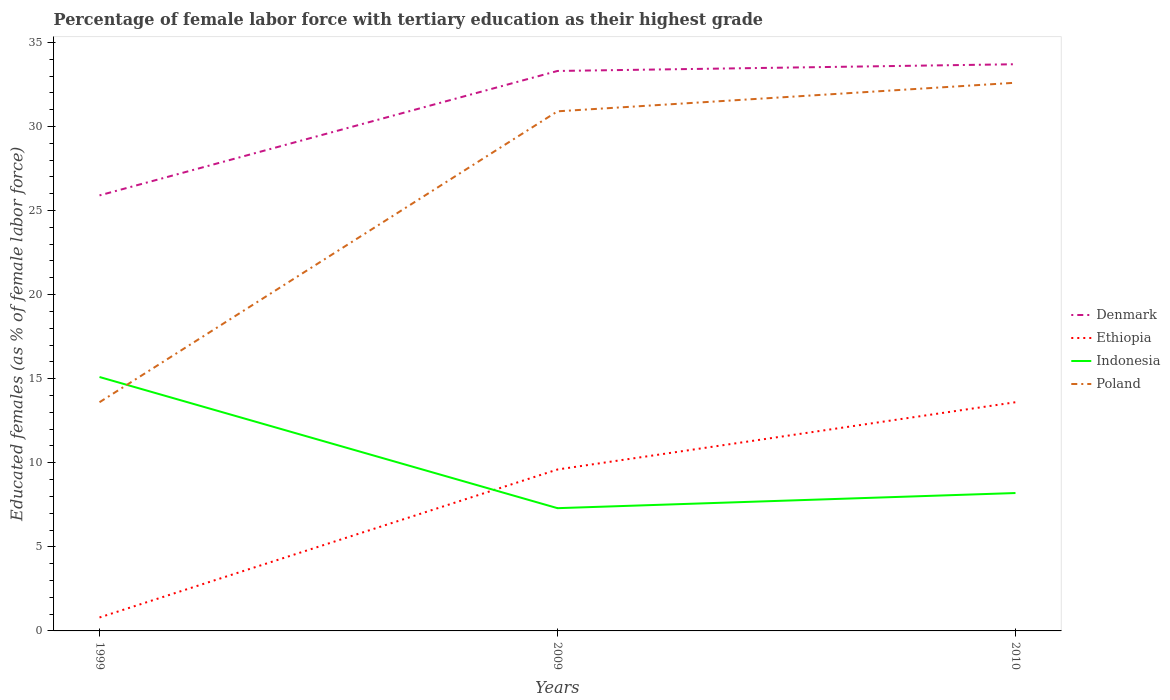Does the line corresponding to Indonesia intersect with the line corresponding to Denmark?
Make the answer very short. No. Is the number of lines equal to the number of legend labels?
Your response must be concise. Yes. Across all years, what is the maximum percentage of female labor force with tertiary education in Poland?
Give a very brief answer. 13.6. What is the total percentage of female labor force with tertiary education in Poland in the graph?
Your answer should be compact. -17.3. What is the difference between the highest and the second highest percentage of female labor force with tertiary education in Poland?
Make the answer very short. 19. How many years are there in the graph?
Ensure brevity in your answer.  3. Are the values on the major ticks of Y-axis written in scientific E-notation?
Offer a terse response. No. Does the graph contain any zero values?
Offer a very short reply. No. Does the graph contain grids?
Keep it short and to the point. No. How many legend labels are there?
Provide a succinct answer. 4. What is the title of the graph?
Make the answer very short. Percentage of female labor force with tertiary education as their highest grade. What is the label or title of the X-axis?
Make the answer very short. Years. What is the label or title of the Y-axis?
Your response must be concise. Educated females (as % of female labor force). What is the Educated females (as % of female labor force) of Denmark in 1999?
Give a very brief answer. 25.9. What is the Educated females (as % of female labor force) of Ethiopia in 1999?
Make the answer very short. 0.8. What is the Educated females (as % of female labor force) of Indonesia in 1999?
Offer a very short reply. 15.1. What is the Educated females (as % of female labor force) of Poland in 1999?
Your answer should be very brief. 13.6. What is the Educated females (as % of female labor force) of Denmark in 2009?
Provide a short and direct response. 33.3. What is the Educated females (as % of female labor force) in Ethiopia in 2009?
Ensure brevity in your answer.  9.6. What is the Educated females (as % of female labor force) in Indonesia in 2009?
Offer a very short reply. 7.3. What is the Educated females (as % of female labor force) of Poland in 2009?
Keep it short and to the point. 30.9. What is the Educated females (as % of female labor force) in Denmark in 2010?
Keep it short and to the point. 33.7. What is the Educated females (as % of female labor force) in Ethiopia in 2010?
Your response must be concise. 13.6. What is the Educated females (as % of female labor force) in Indonesia in 2010?
Provide a succinct answer. 8.2. What is the Educated females (as % of female labor force) of Poland in 2010?
Ensure brevity in your answer.  32.6. Across all years, what is the maximum Educated females (as % of female labor force) in Denmark?
Offer a very short reply. 33.7. Across all years, what is the maximum Educated females (as % of female labor force) in Ethiopia?
Your answer should be very brief. 13.6. Across all years, what is the maximum Educated females (as % of female labor force) in Indonesia?
Your answer should be very brief. 15.1. Across all years, what is the maximum Educated females (as % of female labor force) in Poland?
Offer a very short reply. 32.6. Across all years, what is the minimum Educated females (as % of female labor force) in Denmark?
Your answer should be very brief. 25.9. Across all years, what is the minimum Educated females (as % of female labor force) in Ethiopia?
Provide a succinct answer. 0.8. Across all years, what is the minimum Educated females (as % of female labor force) in Indonesia?
Your answer should be very brief. 7.3. Across all years, what is the minimum Educated females (as % of female labor force) in Poland?
Your response must be concise. 13.6. What is the total Educated females (as % of female labor force) in Denmark in the graph?
Keep it short and to the point. 92.9. What is the total Educated females (as % of female labor force) in Indonesia in the graph?
Your answer should be compact. 30.6. What is the total Educated females (as % of female labor force) in Poland in the graph?
Offer a very short reply. 77.1. What is the difference between the Educated females (as % of female labor force) of Denmark in 1999 and that in 2009?
Give a very brief answer. -7.4. What is the difference between the Educated females (as % of female labor force) of Ethiopia in 1999 and that in 2009?
Keep it short and to the point. -8.8. What is the difference between the Educated females (as % of female labor force) of Poland in 1999 and that in 2009?
Give a very brief answer. -17.3. What is the difference between the Educated females (as % of female labor force) of Indonesia in 1999 and that in 2010?
Offer a terse response. 6.9. What is the difference between the Educated females (as % of female labor force) in Poland in 1999 and that in 2010?
Give a very brief answer. -19. What is the difference between the Educated females (as % of female labor force) in Denmark in 2009 and that in 2010?
Your answer should be compact. -0.4. What is the difference between the Educated females (as % of female labor force) of Indonesia in 2009 and that in 2010?
Offer a terse response. -0.9. What is the difference between the Educated females (as % of female labor force) of Poland in 2009 and that in 2010?
Offer a terse response. -1.7. What is the difference between the Educated females (as % of female labor force) of Denmark in 1999 and the Educated females (as % of female labor force) of Indonesia in 2009?
Your answer should be very brief. 18.6. What is the difference between the Educated females (as % of female labor force) of Denmark in 1999 and the Educated females (as % of female labor force) of Poland in 2009?
Your answer should be compact. -5. What is the difference between the Educated females (as % of female labor force) in Ethiopia in 1999 and the Educated females (as % of female labor force) in Poland in 2009?
Offer a very short reply. -30.1. What is the difference between the Educated females (as % of female labor force) in Indonesia in 1999 and the Educated females (as % of female labor force) in Poland in 2009?
Your answer should be very brief. -15.8. What is the difference between the Educated females (as % of female labor force) in Denmark in 1999 and the Educated females (as % of female labor force) in Ethiopia in 2010?
Your answer should be compact. 12.3. What is the difference between the Educated females (as % of female labor force) in Denmark in 1999 and the Educated females (as % of female labor force) in Indonesia in 2010?
Keep it short and to the point. 17.7. What is the difference between the Educated females (as % of female labor force) in Denmark in 1999 and the Educated females (as % of female labor force) in Poland in 2010?
Ensure brevity in your answer.  -6.7. What is the difference between the Educated females (as % of female labor force) in Ethiopia in 1999 and the Educated females (as % of female labor force) in Indonesia in 2010?
Offer a very short reply. -7.4. What is the difference between the Educated females (as % of female labor force) in Ethiopia in 1999 and the Educated females (as % of female labor force) in Poland in 2010?
Offer a terse response. -31.8. What is the difference between the Educated females (as % of female labor force) in Indonesia in 1999 and the Educated females (as % of female labor force) in Poland in 2010?
Offer a very short reply. -17.5. What is the difference between the Educated females (as % of female labor force) of Denmark in 2009 and the Educated females (as % of female labor force) of Indonesia in 2010?
Your answer should be very brief. 25.1. What is the difference between the Educated females (as % of female labor force) of Denmark in 2009 and the Educated females (as % of female labor force) of Poland in 2010?
Your answer should be compact. 0.7. What is the difference between the Educated females (as % of female labor force) of Indonesia in 2009 and the Educated females (as % of female labor force) of Poland in 2010?
Your answer should be very brief. -25.3. What is the average Educated females (as % of female labor force) of Denmark per year?
Give a very brief answer. 30.97. What is the average Educated females (as % of female labor force) in Ethiopia per year?
Your answer should be very brief. 8. What is the average Educated females (as % of female labor force) of Indonesia per year?
Keep it short and to the point. 10.2. What is the average Educated females (as % of female labor force) of Poland per year?
Your answer should be compact. 25.7. In the year 1999, what is the difference between the Educated females (as % of female labor force) of Denmark and Educated females (as % of female labor force) of Ethiopia?
Offer a very short reply. 25.1. In the year 1999, what is the difference between the Educated females (as % of female labor force) of Denmark and Educated females (as % of female labor force) of Indonesia?
Offer a terse response. 10.8. In the year 1999, what is the difference between the Educated females (as % of female labor force) of Denmark and Educated females (as % of female labor force) of Poland?
Your answer should be compact. 12.3. In the year 1999, what is the difference between the Educated females (as % of female labor force) in Ethiopia and Educated females (as % of female labor force) in Indonesia?
Your answer should be compact. -14.3. In the year 1999, what is the difference between the Educated females (as % of female labor force) of Ethiopia and Educated females (as % of female labor force) of Poland?
Your response must be concise. -12.8. In the year 2009, what is the difference between the Educated females (as % of female labor force) of Denmark and Educated females (as % of female labor force) of Ethiopia?
Ensure brevity in your answer.  23.7. In the year 2009, what is the difference between the Educated females (as % of female labor force) in Denmark and Educated females (as % of female labor force) in Poland?
Your answer should be very brief. 2.4. In the year 2009, what is the difference between the Educated females (as % of female labor force) in Ethiopia and Educated females (as % of female labor force) in Poland?
Your response must be concise. -21.3. In the year 2009, what is the difference between the Educated females (as % of female labor force) of Indonesia and Educated females (as % of female labor force) of Poland?
Make the answer very short. -23.6. In the year 2010, what is the difference between the Educated females (as % of female labor force) of Denmark and Educated females (as % of female labor force) of Ethiopia?
Provide a succinct answer. 20.1. In the year 2010, what is the difference between the Educated females (as % of female labor force) in Ethiopia and Educated females (as % of female labor force) in Poland?
Offer a terse response. -19. In the year 2010, what is the difference between the Educated females (as % of female labor force) in Indonesia and Educated females (as % of female labor force) in Poland?
Your answer should be compact. -24.4. What is the ratio of the Educated females (as % of female labor force) in Denmark in 1999 to that in 2009?
Give a very brief answer. 0.78. What is the ratio of the Educated females (as % of female labor force) in Ethiopia in 1999 to that in 2009?
Make the answer very short. 0.08. What is the ratio of the Educated females (as % of female labor force) in Indonesia in 1999 to that in 2009?
Offer a very short reply. 2.07. What is the ratio of the Educated females (as % of female labor force) of Poland in 1999 to that in 2009?
Offer a very short reply. 0.44. What is the ratio of the Educated females (as % of female labor force) in Denmark in 1999 to that in 2010?
Keep it short and to the point. 0.77. What is the ratio of the Educated females (as % of female labor force) in Ethiopia in 1999 to that in 2010?
Provide a succinct answer. 0.06. What is the ratio of the Educated females (as % of female labor force) of Indonesia in 1999 to that in 2010?
Provide a short and direct response. 1.84. What is the ratio of the Educated females (as % of female labor force) in Poland in 1999 to that in 2010?
Your answer should be compact. 0.42. What is the ratio of the Educated females (as % of female labor force) in Ethiopia in 2009 to that in 2010?
Your response must be concise. 0.71. What is the ratio of the Educated females (as % of female labor force) in Indonesia in 2009 to that in 2010?
Ensure brevity in your answer.  0.89. What is the ratio of the Educated females (as % of female labor force) of Poland in 2009 to that in 2010?
Provide a short and direct response. 0.95. What is the difference between the highest and the second highest Educated females (as % of female labor force) in Denmark?
Provide a short and direct response. 0.4. What is the difference between the highest and the second highest Educated females (as % of female labor force) in Ethiopia?
Your answer should be compact. 4. What is the difference between the highest and the lowest Educated females (as % of female labor force) of Indonesia?
Make the answer very short. 7.8. 